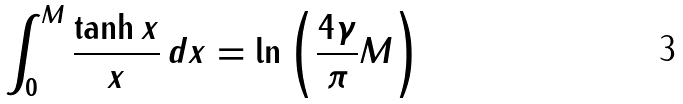<formula> <loc_0><loc_0><loc_500><loc_500>\int _ { 0 } ^ { M } \frac { \tanh x } { x } \, d x = \ln \left ( \frac { 4 \gamma } { \pi } M \right )</formula> 